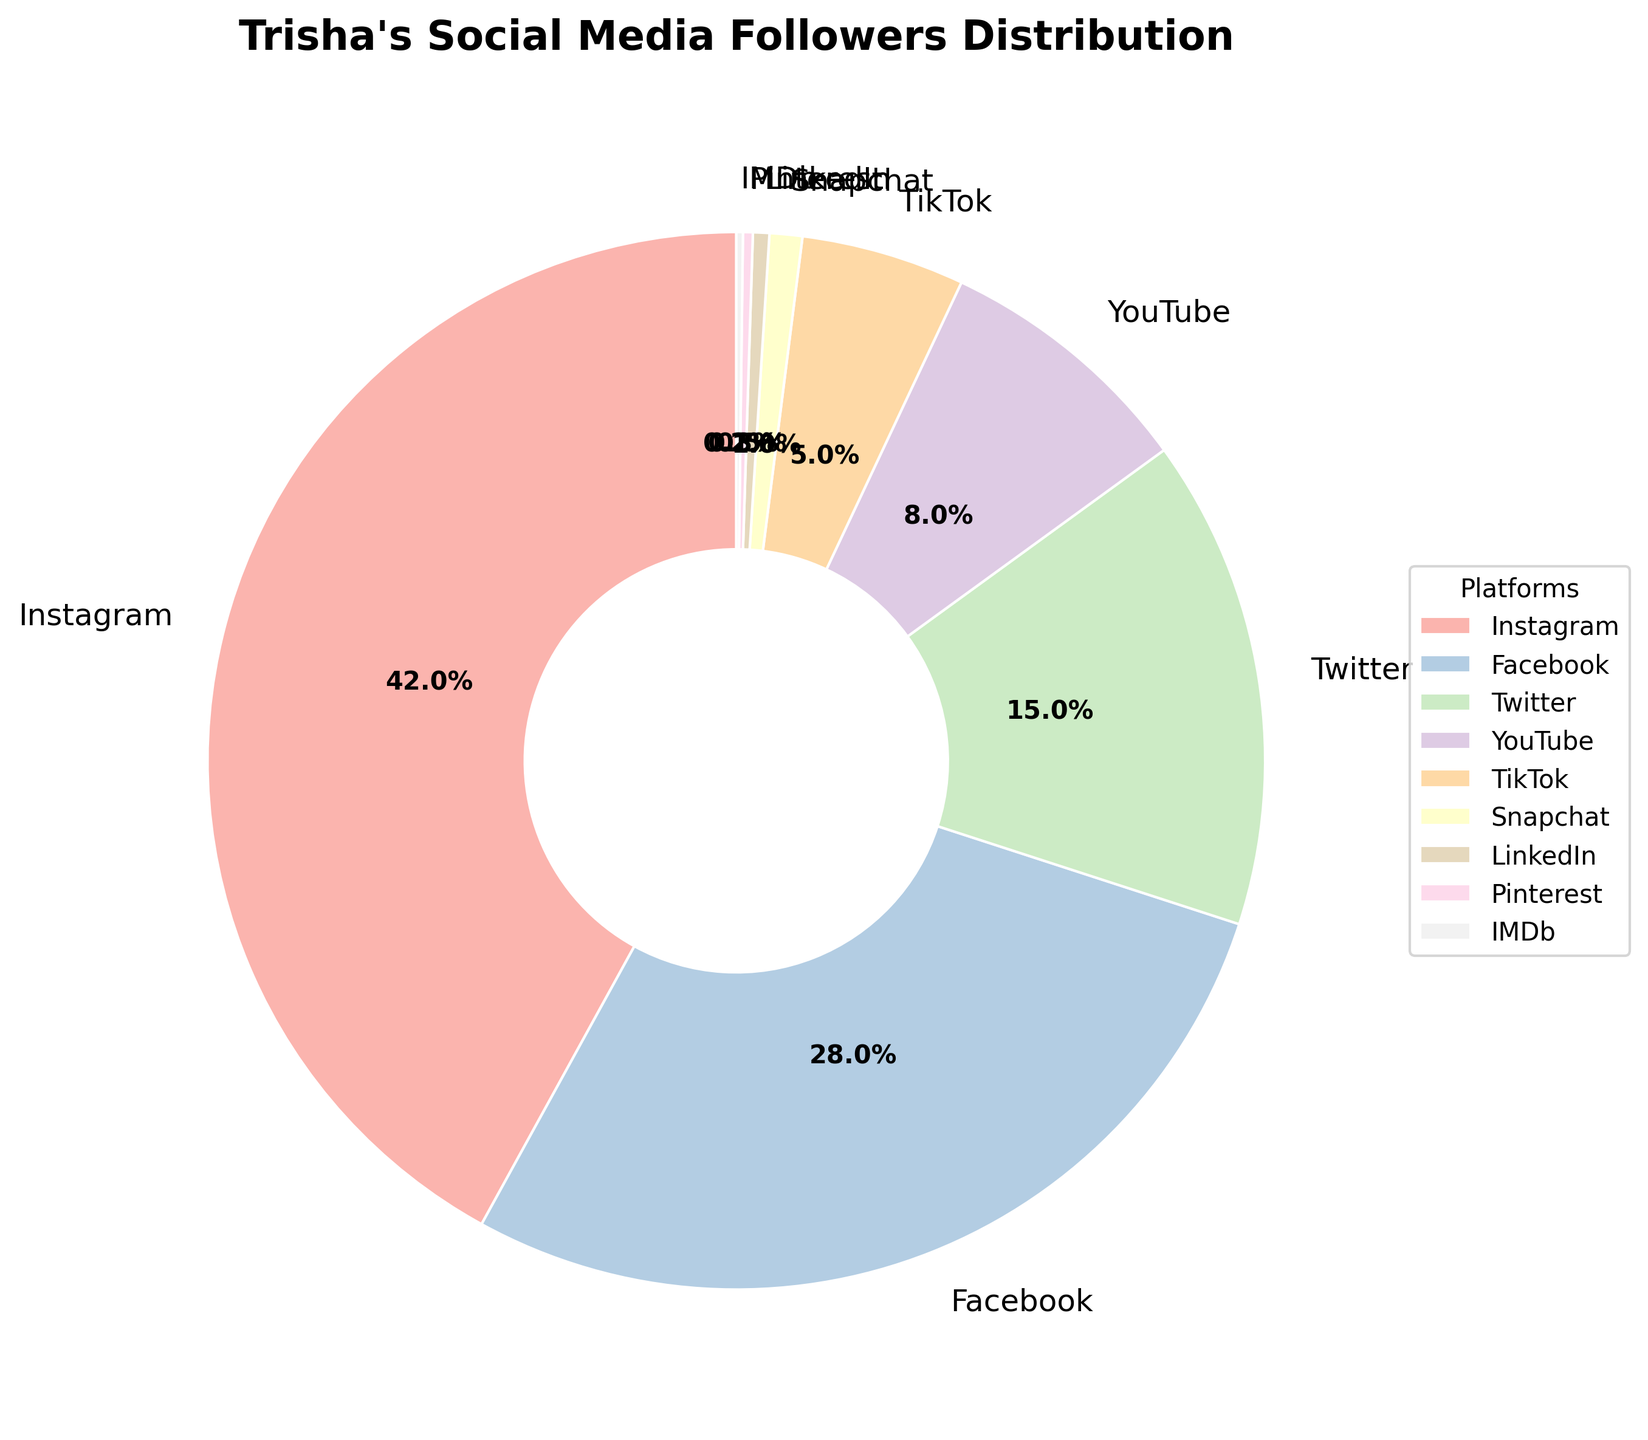What percentage of Trisha's social media followers are on Instagram? From the pie chart, we can see that Instagram has the largest wedge labeled with its percentage. Referring to the label, Instagram holds 42% of Trisha's social media followers.
Answer: 42% Which platform has the smallest percentage of Trisha's social media followers? Observing the pie chart, the smallest wedge is labeled IMDb, which shows the smallest percentage of 0.2%.
Answer: IMDb How much higher is the percentage of followers on Facebook compared to YouTube? From the chart, Facebook has 28% and YouTube has 8%. The difference is calculated as 28% - 8%. So, the percentage is 20% higher.
Answer: 20% Which two platforms combined have over 70% of Trisha's followers? By looking at the chart, Instagram has 42% and Facebook has 28%. Summing these up is 42% + 28% = 70%, which matches exactly 70%. Thus, Instagram and Facebook together have 70%.
Answer: Instagram and Facebook Rank the platforms from the highest to the lowest follower percentage. Referring to the chart, we list out all percentages: Instagram (42%), Facebook (28%), Twitter (15%), YouTube (8%), TikTok (5%), Snapchat (1%), LinkedIn (0.5%), Pinterest (0.3%), and IMDb (0.2%). Arranging these in descending order, the ranking is: Instagram, Facebook, Twitter, YouTube, TikTok, Snapchat, LinkedIn, Pinterest, IMDb.
Answer: Instagram, Facebook, Twitter, YouTube, TikTok, Snapchat, LinkedIn, Pinterest, IMDb Which platform has a percentage closest to 5%, and what is the percentage? From the pie chart, TikTok has a percentage of 5%, exactly matching our value of interest.
Answer: TikTok, 5% By how much is the Twitter follower percentage less than the combined percentage of LinkedIn, Pinterest, and IMDb? The combined percentage of LinkedIn, Pinterest, and IMDb is 0.5% + 0.3% + 0.2% = 1%. Twitter has a percentage of 15%. The difference is calculated as 15% - 1% = 14%.
Answer: 14% What percentage of followers are on platforms other than Instagram, Facebook, and Twitter? Adding the percentages of platforms other than Instagram (42%), Facebook (28%), and Twitter (15%), we have: 100% - (42% + 28% + 15%) = 100% - 85% = 15%.
Answer: 15% 